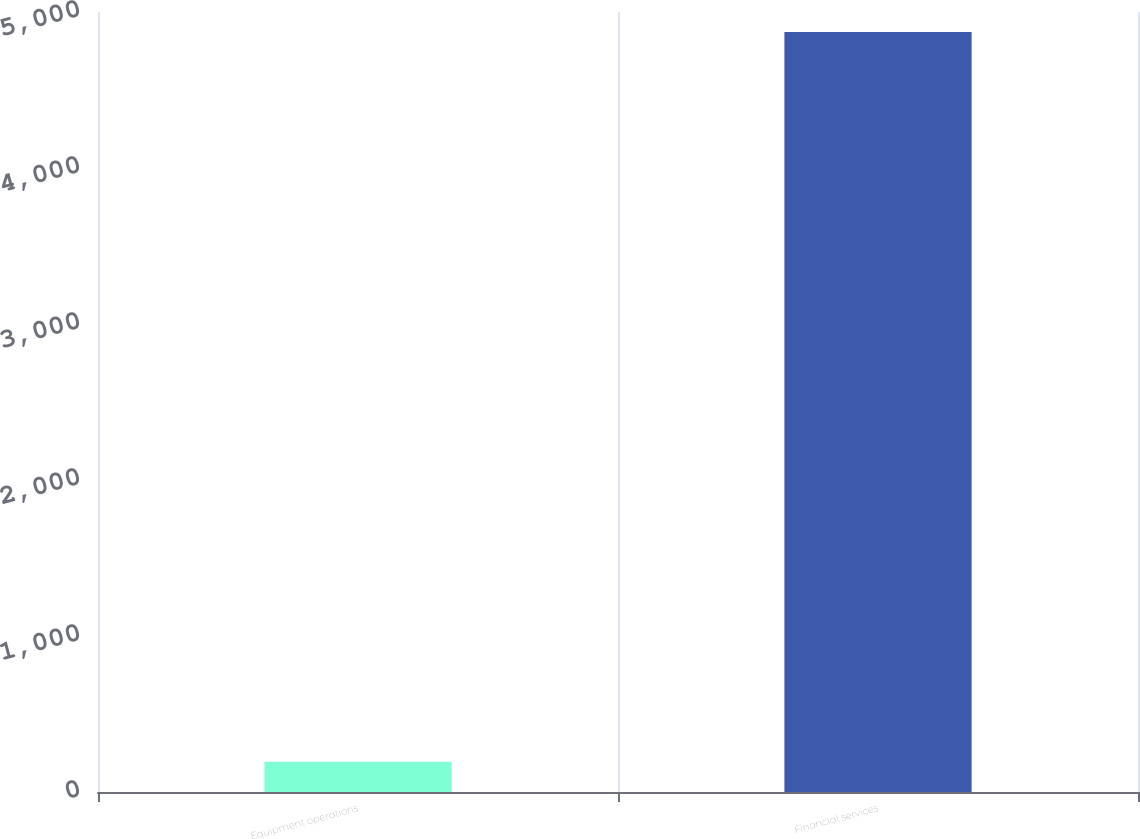Convert chart. <chart><loc_0><loc_0><loc_500><loc_500><bar_chart><fcel>Equipment operations<fcel>Financial services<nl><fcel>194<fcel>4871<nl></chart> 